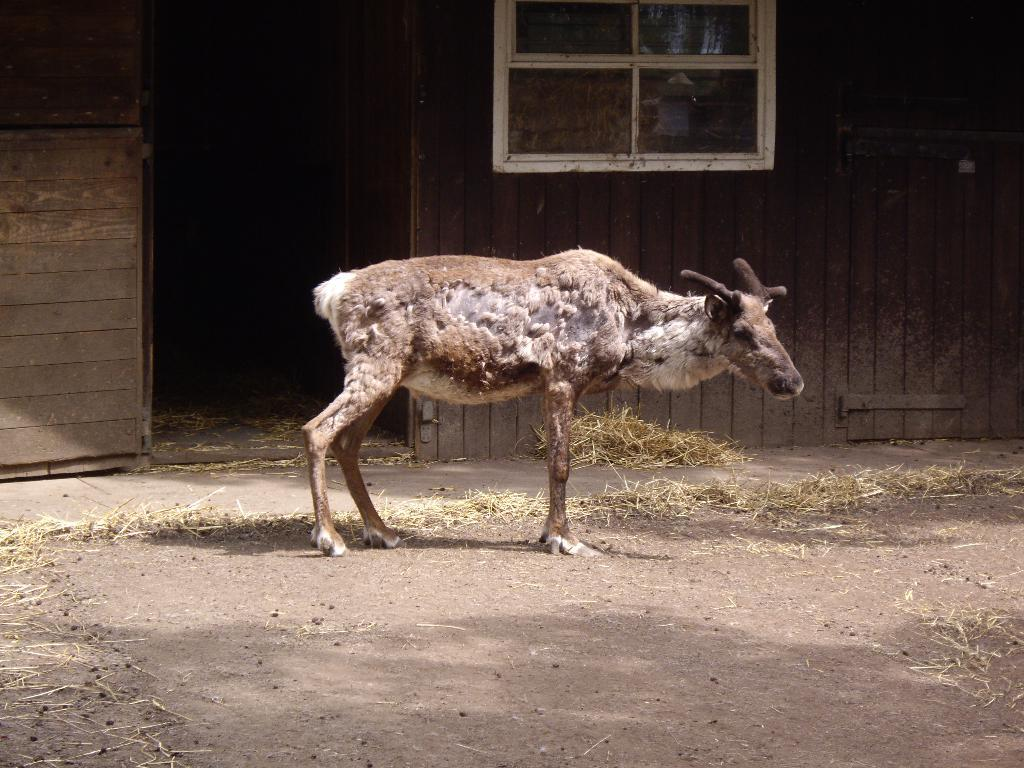What type of animal can be seen on the ground in the image? There is an animal on the ground in the image, but the specific type cannot be determined from the provided facts. What type of vegetation is visible in the image? There is grass visible in the image. What type of structure can be seen in the background of the image? There is a wooden house in the background of the image. What type of hospital can be seen in the image? There is no hospital present in the image; it features an animal on the ground, grass, and a wooden house in the background. 